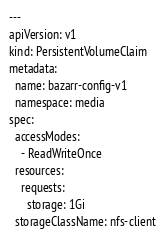Convert code to text. <code><loc_0><loc_0><loc_500><loc_500><_YAML_>---
apiVersion: v1
kind: PersistentVolumeClaim
metadata:
  name: bazarr-config-v1
  namespace: media
spec:
  accessModes:
    - ReadWriteOnce
  resources:
    requests:
      storage: 1Gi
  storageClassName: nfs-client
</code> 